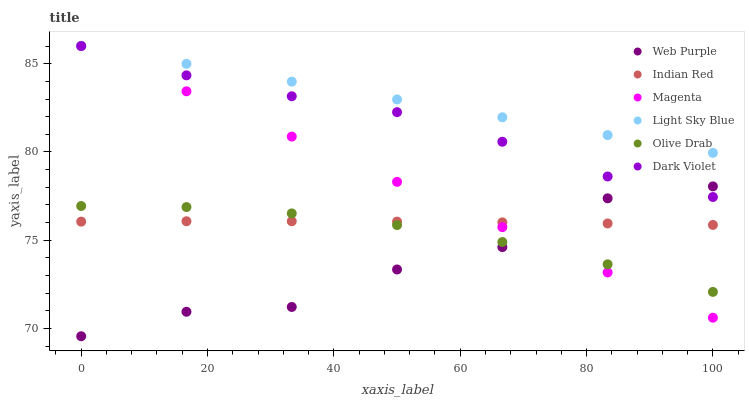Does Web Purple have the minimum area under the curve?
Answer yes or no. Yes. Does Light Sky Blue have the maximum area under the curve?
Answer yes or no. Yes. Does Light Sky Blue have the minimum area under the curve?
Answer yes or no. No. Does Web Purple have the maximum area under the curve?
Answer yes or no. No. Is Magenta the smoothest?
Answer yes or no. Yes. Is Web Purple the roughest?
Answer yes or no. Yes. Is Light Sky Blue the smoothest?
Answer yes or no. No. Is Light Sky Blue the roughest?
Answer yes or no. No. Does Web Purple have the lowest value?
Answer yes or no. Yes. Does Light Sky Blue have the lowest value?
Answer yes or no. No. Does Magenta have the highest value?
Answer yes or no. Yes. Does Web Purple have the highest value?
Answer yes or no. No. Is Olive Drab less than Dark Violet?
Answer yes or no. Yes. Is Light Sky Blue greater than Indian Red?
Answer yes or no. Yes. Does Web Purple intersect Olive Drab?
Answer yes or no. Yes. Is Web Purple less than Olive Drab?
Answer yes or no. No. Is Web Purple greater than Olive Drab?
Answer yes or no. No. Does Olive Drab intersect Dark Violet?
Answer yes or no. No. 